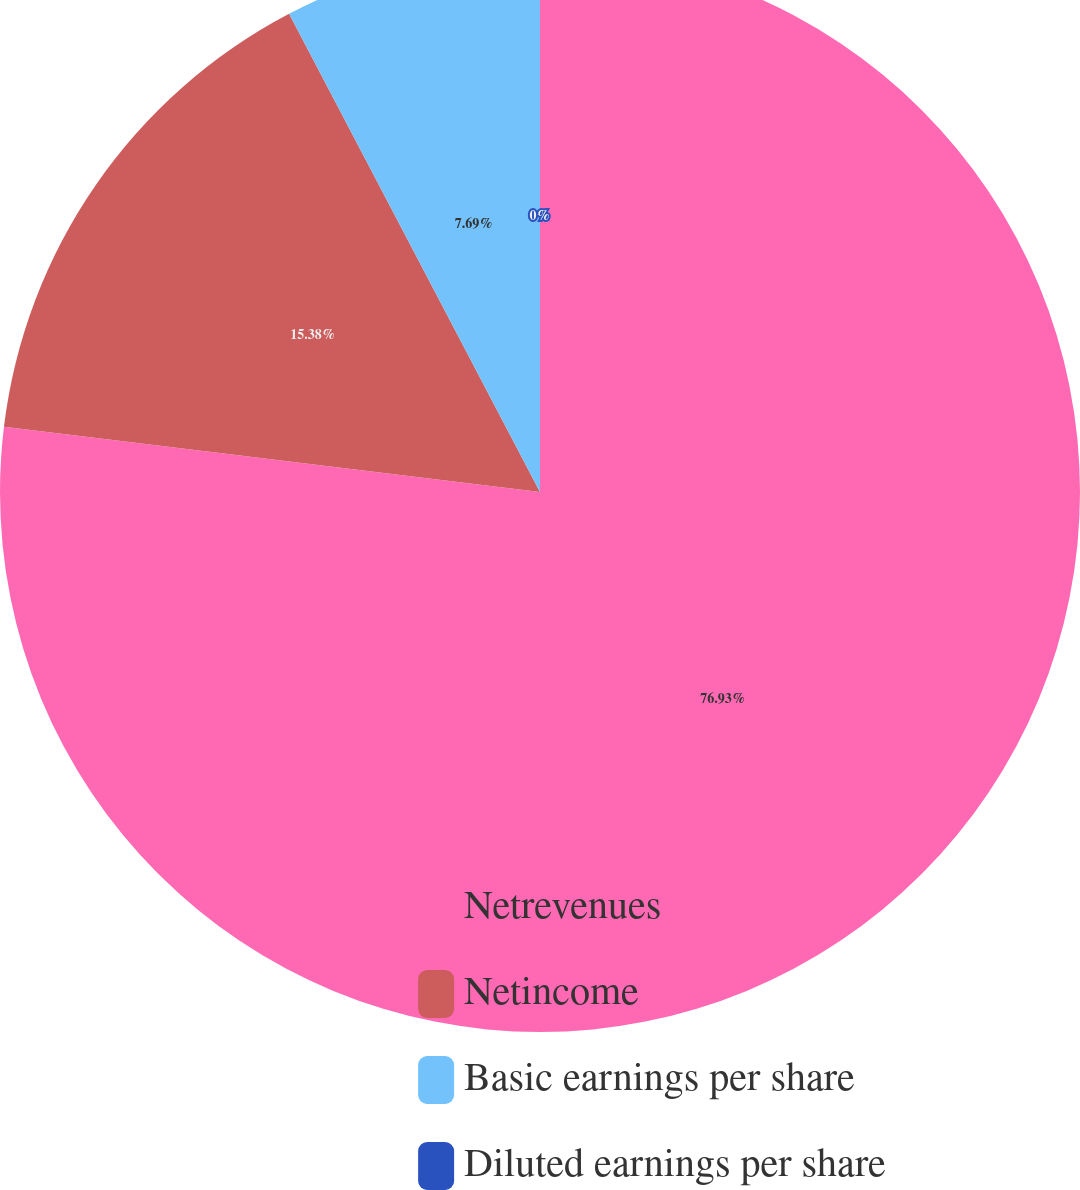Convert chart to OTSL. <chart><loc_0><loc_0><loc_500><loc_500><pie_chart><fcel>Netrevenues<fcel>Netincome<fcel>Basic earnings per share<fcel>Diluted earnings per share<nl><fcel>76.92%<fcel>15.38%<fcel>7.69%<fcel>0.0%<nl></chart> 